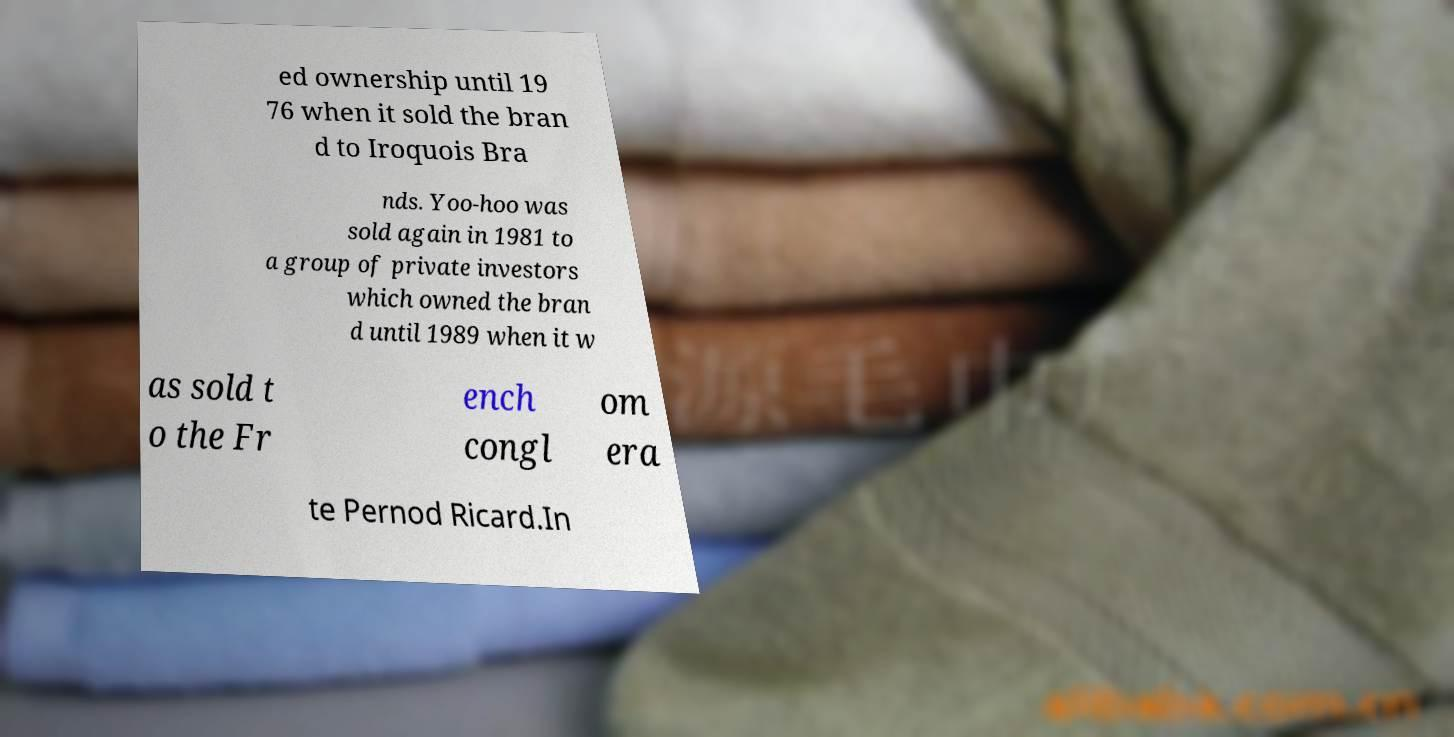Can you accurately transcribe the text from the provided image for me? ed ownership until 19 76 when it sold the bran d to Iroquois Bra nds. Yoo-hoo was sold again in 1981 to a group of private investors which owned the bran d until 1989 when it w as sold t o the Fr ench congl om era te Pernod Ricard.In 